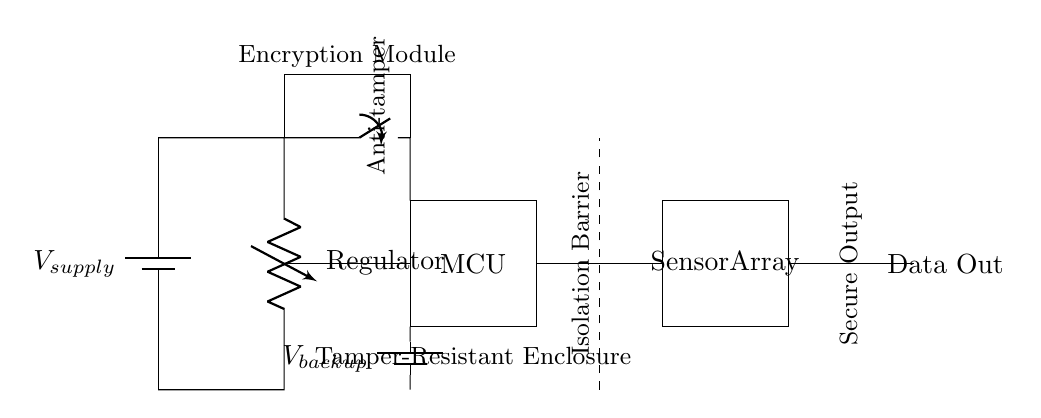What is the main power source in this circuit? The main power source is the battery labeled V_supply, which provides the necessary voltage to power the circuit components.
Answer: V_supply What component is responsible for data output? The data output is handled by the component labeled Data Out, which allows the processed information to be communicated externally.
Answer: Data Out What type of switch is included in the circuit? The circuit features a single pole single throw (spst) switch, which is used to control the anti-tampering feature.
Answer: Anti-tamper switch How does the encryption module relate to data security in this circuit? The encryption module ensures that any data output from the circuit is secured, preventing unauthorized access as it encrypts the transmitted data.
Answer: Enhances data security What is the purpose of the isolation barrier? The isolation barrier is designed to separate different parts of the circuit, ensuring electrical safety and preventing interference between components.
Answer: Prevents interference What additional power source is included for backup? The circuit includes a backup battery labeled V_backup, which provides an alternative power source in case the main supply is unavailable.
Answer: V_backup How many main functional blocks are there in the circuit? The circuit can be seen to have four main functional blocks: the power supply, the microcontroller, the sensor array, and the encryption module.
Answer: Four 